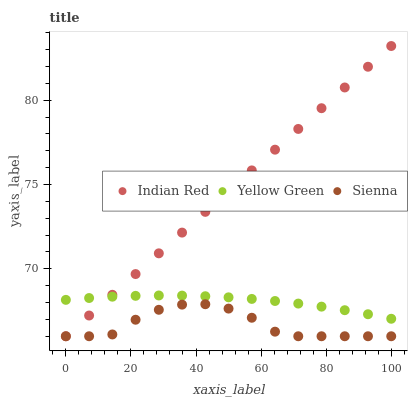Does Sienna have the minimum area under the curve?
Answer yes or no. Yes. Does Indian Red have the maximum area under the curve?
Answer yes or no. Yes. Does Yellow Green have the minimum area under the curve?
Answer yes or no. No. Does Yellow Green have the maximum area under the curve?
Answer yes or no. No. Is Indian Red the smoothest?
Answer yes or no. Yes. Is Sienna the roughest?
Answer yes or no. Yes. Is Yellow Green the smoothest?
Answer yes or no. No. Is Yellow Green the roughest?
Answer yes or no. No. Does Sienna have the lowest value?
Answer yes or no. Yes. Does Yellow Green have the lowest value?
Answer yes or no. No. Does Indian Red have the highest value?
Answer yes or no. Yes. Does Yellow Green have the highest value?
Answer yes or no. No. Is Sienna less than Yellow Green?
Answer yes or no. Yes. Is Yellow Green greater than Sienna?
Answer yes or no. Yes. Does Yellow Green intersect Indian Red?
Answer yes or no. Yes. Is Yellow Green less than Indian Red?
Answer yes or no. No. Is Yellow Green greater than Indian Red?
Answer yes or no. No. Does Sienna intersect Yellow Green?
Answer yes or no. No. 